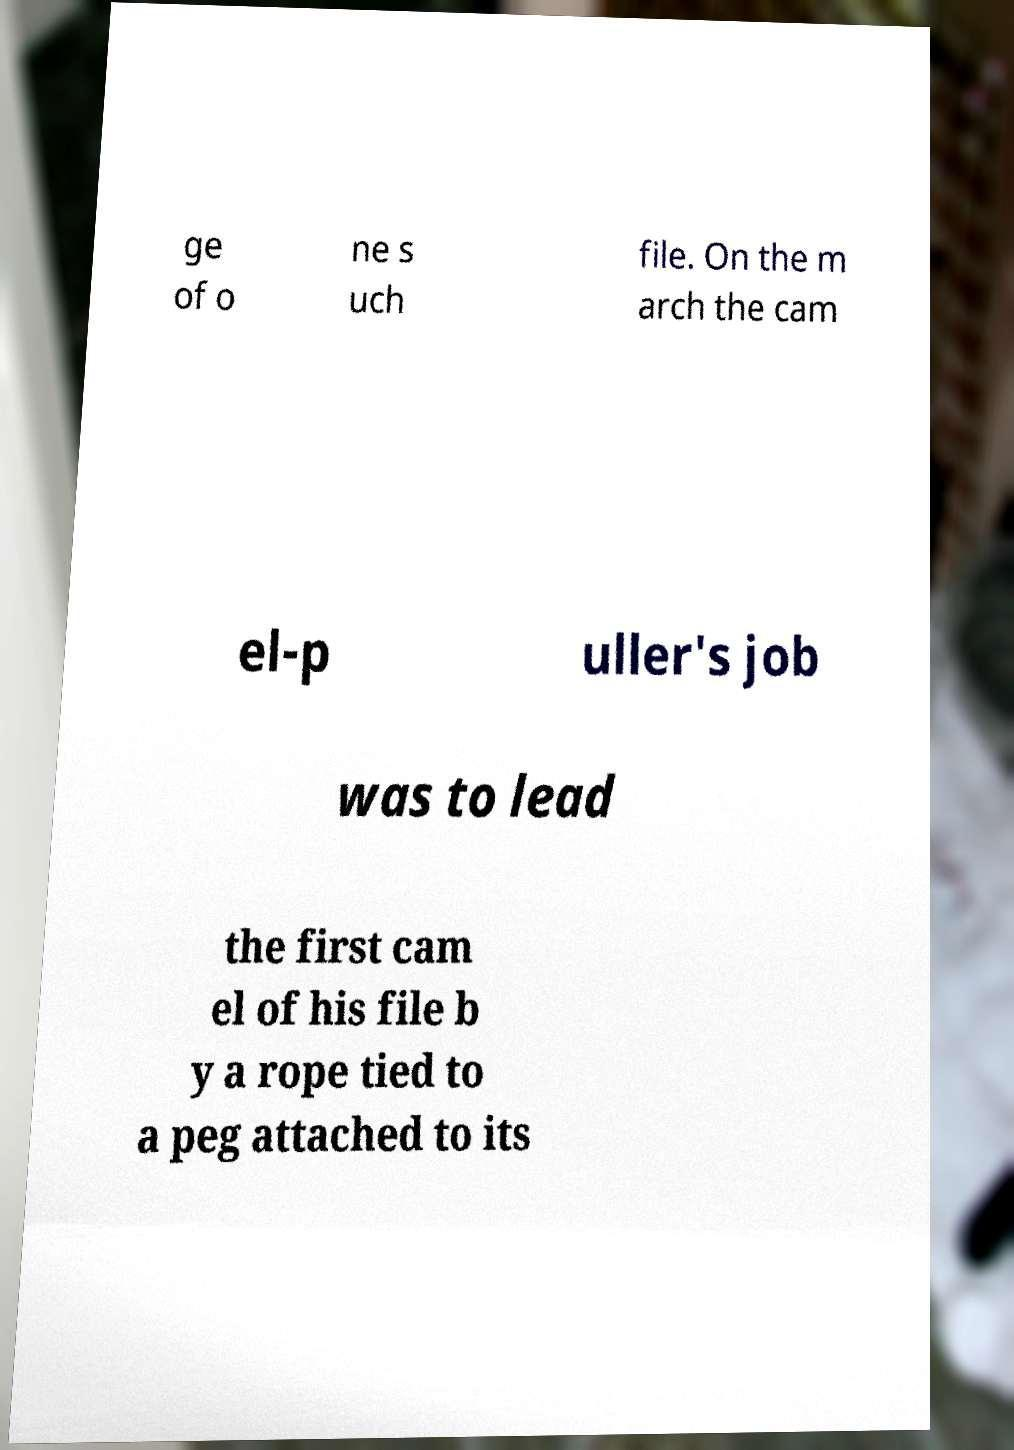Could you assist in decoding the text presented in this image and type it out clearly? ge of o ne s uch file. On the m arch the cam el-p uller's job was to lead the first cam el of his file b y a rope tied to a peg attached to its 